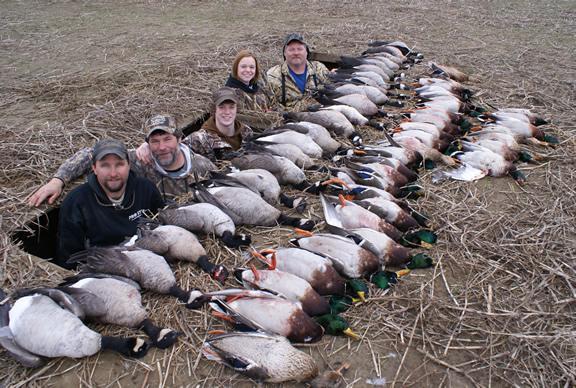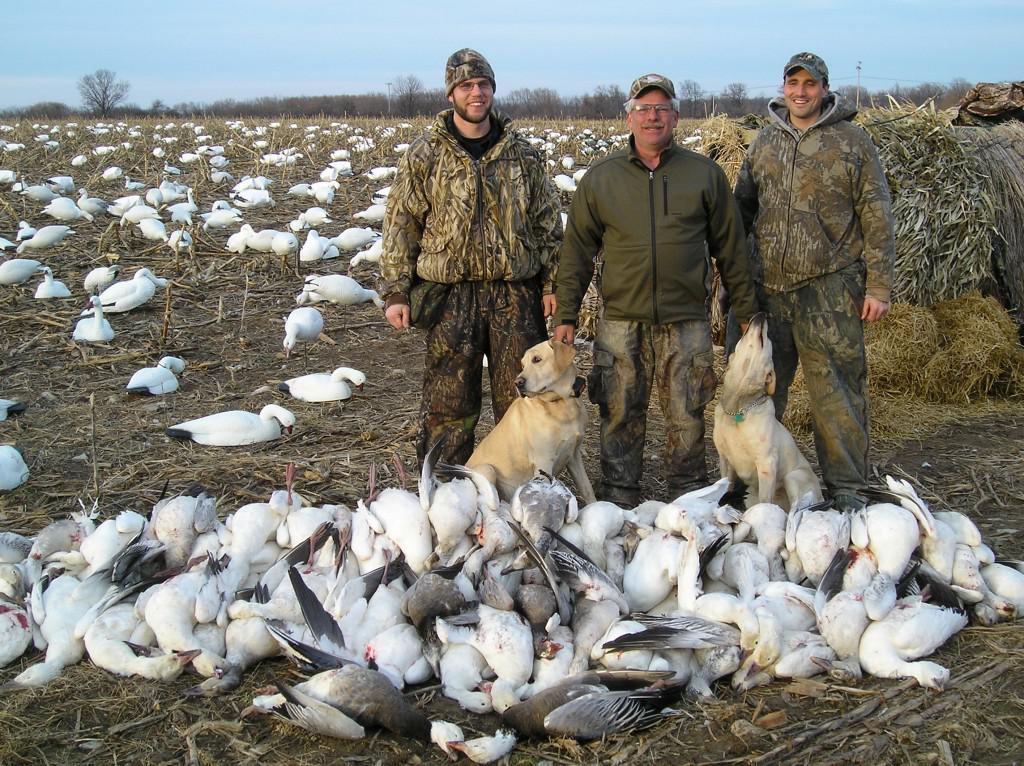The first image is the image on the left, the second image is the image on the right. For the images shown, is this caption "An image includes at least one hunter, dog and many dead birds." true? Answer yes or no. Yes. The first image is the image on the left, the second image is the image on the right. Evaluate the accuracy of this statement regarding the images: "One of the photos contains one or more dogs.". Is it true? Answer yes or no. Yes. 